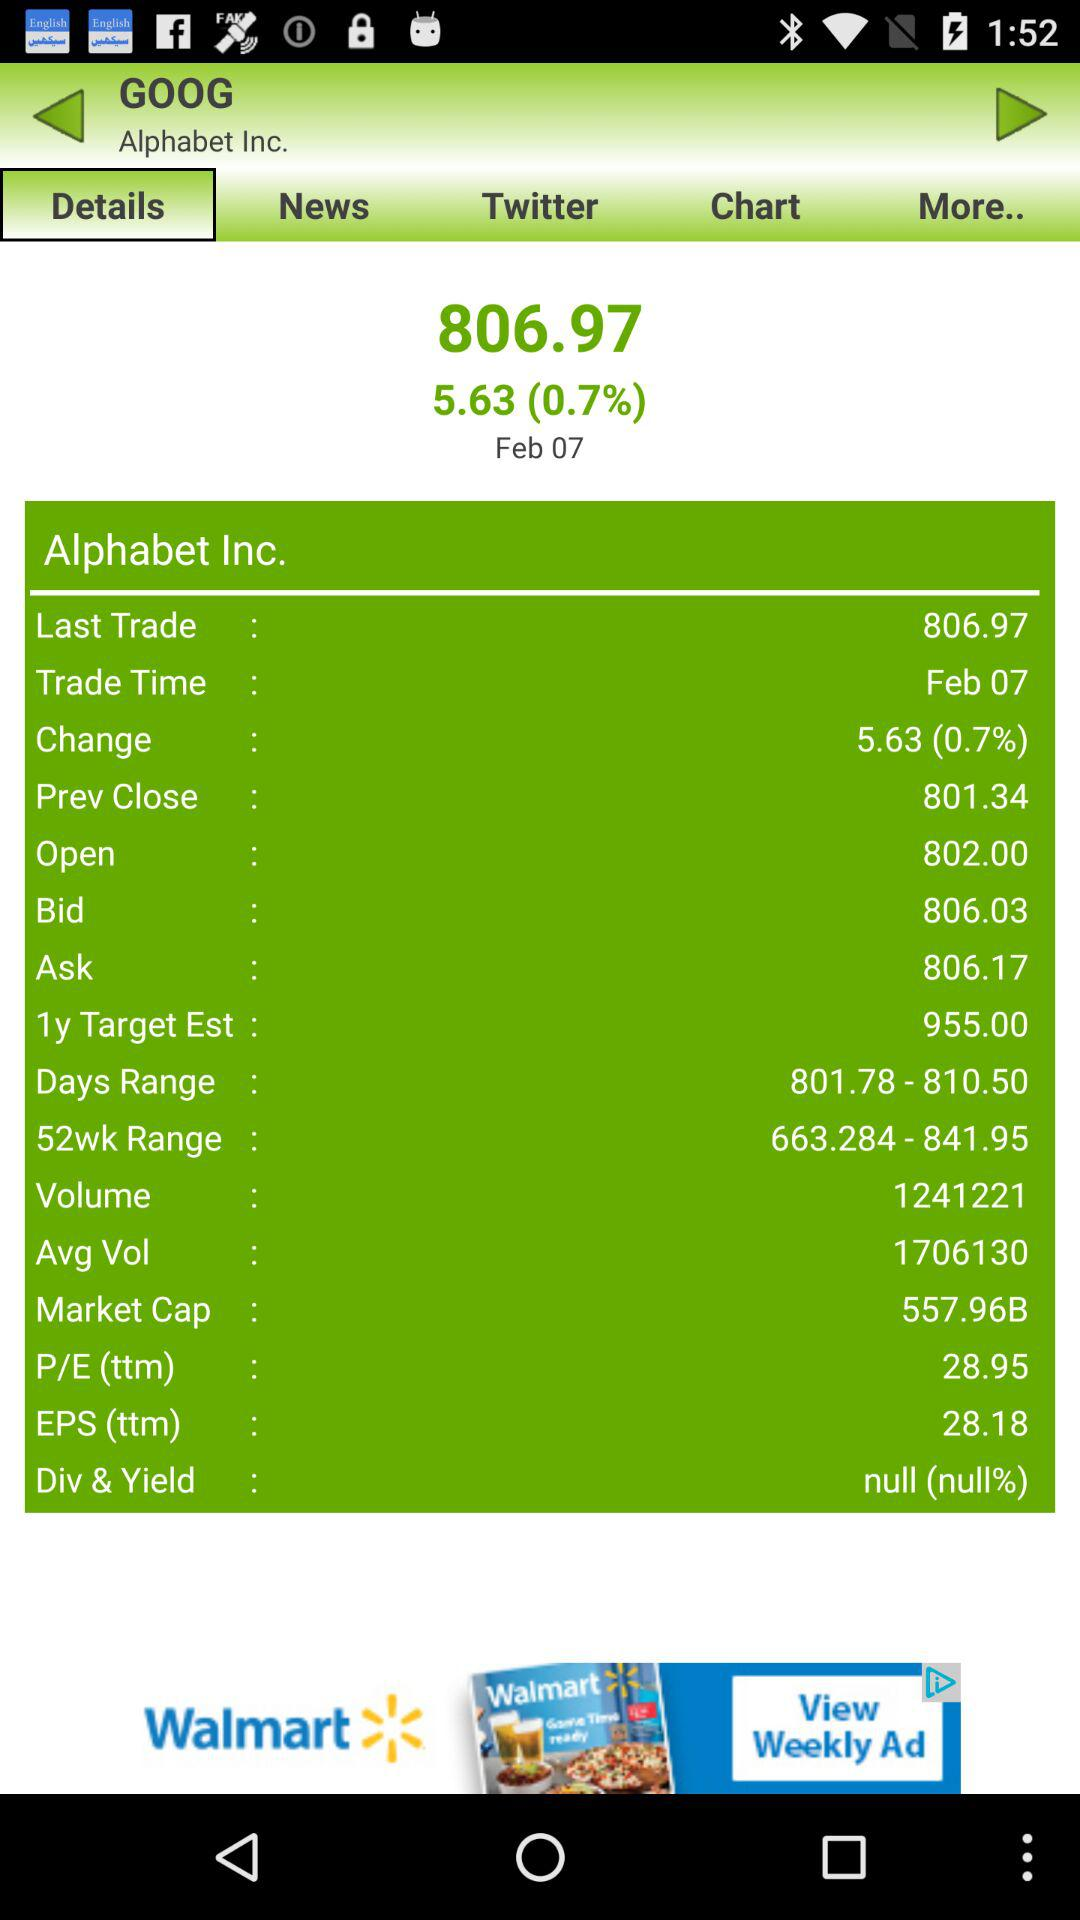What is the "Div & Yield" percentage in "Alphabet Inc."? The "Div & Yield" percentage in "Alphabet Inc." is null. 